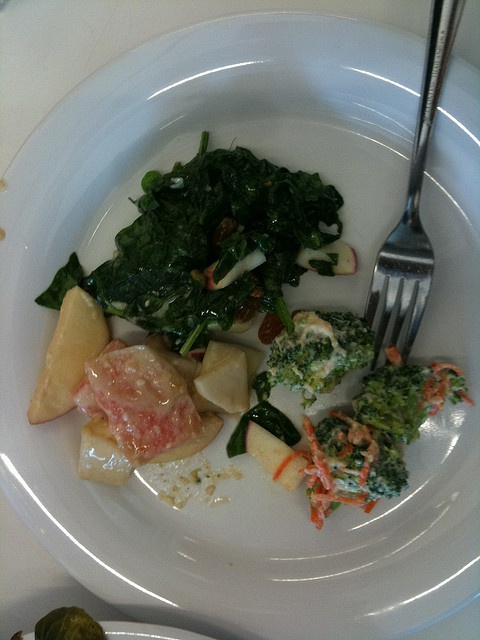Describe the objects in this image and their specific colors. I can see fork in gray, black, and purple tones, broccoli in gray, black, and darkgreen tones, apple in gray and olive tones, broccoli in gray, black, olive, and maroon tones, and broccoli in gray, black, and darkgreen tones in this image. 